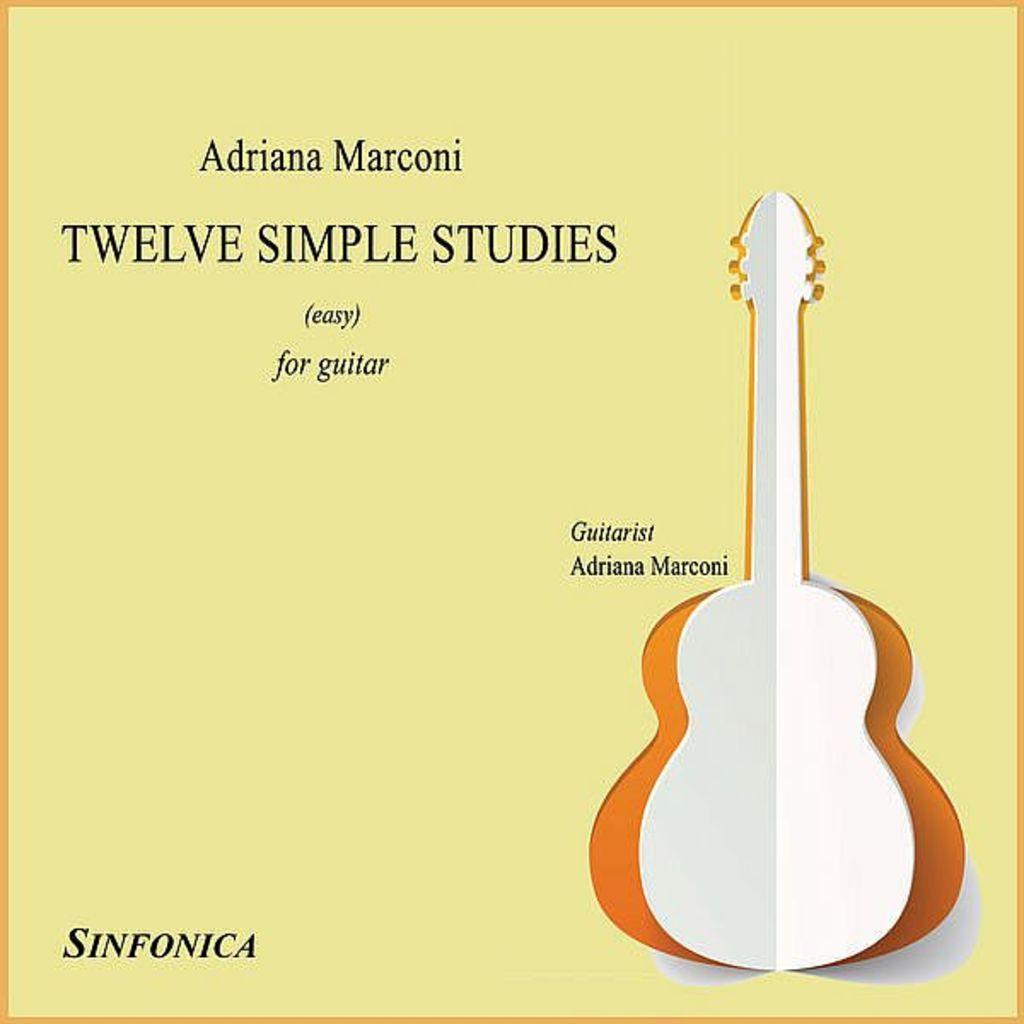In one or two sentences, can you explain what this image depicts? This is a poster and here we can see a guitar and some text written. 